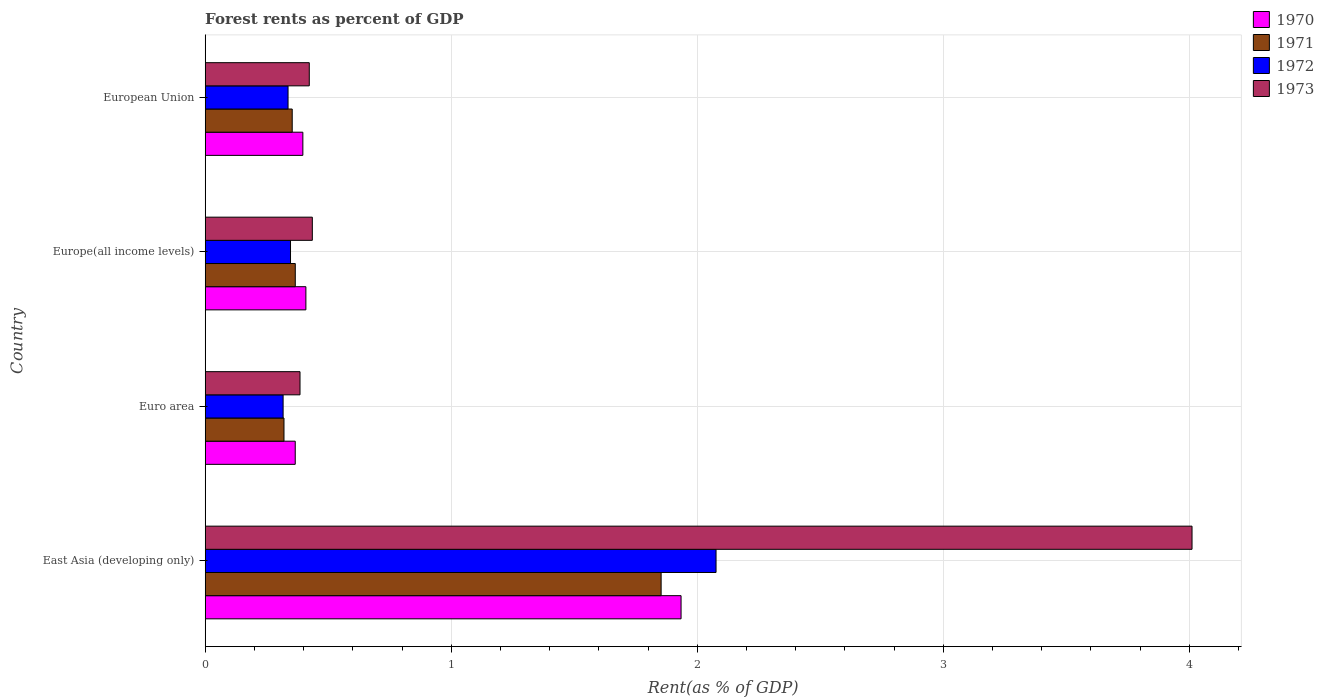How many groups of bars are there?
Give a very brief answer. 4. Are the number of bars per tick equal to the number of legend labels?
Keep it short and to the point. Yes. Are the number of bars on each tick of the Y-axis equal?
Give a very brief answer. Yes. How many bars are there on the 3rd tick from the top?
Offer a terse response. 4. How many bars are there on the 2nd tick from the bottom?
Make the answer very short. 4. What is the forest rent in 1971 in Euro area?
Ensure brevity in your answer.  0.32. Across all countries, what is the maximum forest rent in 1973?
Offer a very short reply. 4.01. Across all countries, what is the minimum forest rent in 1970?
Make the answer very short. 0.37. In which country was the forest rent in 1973 maximum?
Your answer should be very brief. East Asia (developing only). In which country was the forest rent in 1970 minimum?
Offer a very short reply. Euro area. What is the total forest rent in 1970 in the graph?
Your answer should be compact. 3.11. What is the difference between the forest rent in 1972 in East Asia (developing only) and that in European Union?
Provide a succinct answer. 1.74. What is the difference between the forest rent in 1973 in Euro area and the forest rent in 1972 in European Union?
Provide a short and direct response. 0.05. What is the average forest rent in 1970 per country?
Your answer should be very brief. 0.78. What is the difference between the forest rent in 1970 and forest rent in 1971 in Europe(all income levels)?
Give a very brief answer. 0.04. In how many countries, is the forest rent in 1973 greater than 2.6 %?
Make the answer very short. 1. What is the ratio of the forest rent in 1972 in East Asia (developing only) to that in European Union?
Ensure brevity in your answer.  6.17. What is the difference between the highest and the second highest forest rent in 1970?
Offer a very short reply. 1.52. What is the difference between the highest and the lowest forest rent in 1973?
Offer a terse response. 3.63. In how many countries, is the forest rent in 1972 greater than the average forest rent in 1972 taken over all countries?
Keep it short and to the point. 1. Is the sum of the forest rent in 1970 in Euro area and European Union greater than the maximum forest rent in 1972 across all countries?
Provide a succinct answer. No. Is it the case that in every country, the sum of the forest rent in 1970 and forest rent in 1971 is greater than the sum of forest rent in 1972 and forest rent in 1973?
Ensure brevity in your answer.  Yes. What does the 1st bar from the bottom in Europe(all income levels) represents?
Provide a succinct answer. 1970. How many countries are there in the graph?
Provide a succinct answer. 4. Does the graph contain any zero values?
Give a very brief answer. No. Does the graph contain grids?
Keep it short and to the point. Yes. How many legend labels are there?
Keep it short and to the point. 4. How are the legend labels stacked?
Provide a succinct answer. Vertical. What is the title of the graph?
Your response must be concise. Forest rents as percent of GDP. Does "1960" appear as one of the legend labels in the graph?
Keep it short and to the point. No. What is the label or title of the X-axis?
Keep it short and to the point. Rent(as % of GDP). What is the label or title of the Y-axis?
Ensure brevity in your answer.  Country. What is the Rent(as % of GDP) of 1970 in East Asia (developing only)?
Your response must be concise. 1.93. What is the Rent(as % of GDP) of 1971 in East Asia (developing only)?
Your response must be concise. 1.85. What is the Rent(as % of GDP) in 1972 in East Asia (developing only)?
Offer a terse response. 2.08. What is the Rent(as % of GDP) of 1973 in East Asia (developing only)?
Offer a very short reply. 4.01. What is the Rent(as % of GDP) of 1970 in Euro area?
Your response must be concise. 0.37. What is the Rent(as % of GDP) of 1971 in Euro area?
Provide a short and direct response. 0.32. What is the Rent(as % of GDP) in 1972 in Euro area?
Offer a very short reply. 0.32. What is the Rent(as % of GDP) of 1973 in Euro area?
Make the answer very short. 0.39. What is the Rent(as % of GDP) of 1970 in Europe(all income levels)?
Offer a very short reply. 0.41. What is the Rent(as % of GDP) of 1971 in Europe(all income levels)?
Your answer should be compact. 0.37. What is the Rent(as % of GDP) in 1972 in Europe(all income levels)?
Your response must be concise. 0.35. What is the Rent(as % of GDP) in 1973 in Europe(all income levels)?
Your answer should be compact. 0.44. What is the Rent(as % of GDP) in 1970 in European Union?
Keep it short and to the point. 0.4. What is the Rent(as % of GDP) of 1971 in European Union?
Your response must be concise. 0.35. What is the Rent(as % of GDP) of 1972 in European Union?
Provide a succinct answer. 0.34. What is the Rent(as % of GDP) in 1973 in European Union?
Keep it short and to the point. 0.42. Across all countries, what is the maximum Rent(as % of GDP) in 1970?
Offer a terse response. 1.93. Across all countries, what is the maximum Rent(as % of GDP) in 1971?
Make the answer very short. 1.85. Across all countries, what is the maximum Rent(as % of GDP) in 1972?
Ensure brevity in your answer.  2.08. Across all countries, what is the maximum Rent(as % of GDP) in 1973?
Offer a terse response. 4.01. Across all countries, what is the minimum Rent(as % of GDP) in 1970?
Make the answer very short. 0.37. Across all countries, what is the minimum Rent(as % of GDP) in 1971?
Provide a short and direct response. 0.32. Across all countries, what is the minimum Rent(as % of GDP) of 1972?
Make the answer very short. 0.32. Across all countries, what is the minimum Rent(as % of GDP) in 1973?
Make the answer very short. 0.39. What is the total Rent(as % of GDP) in 1970 in the graph?
Your answer should be very brief. 3.11. What is the total Rent(as % of GDP) of 1971 in the graph?
Give a very brief answer. 2.89. What is the total Rent(as % of GDP) in 1972 in the graph?
Your answer should be compact. 3.08. What is the total Rent(as % of GDP) of 1973 in the graph?
Keep it short and to the point. 5.25. What is the difference between the Rent(as % of GDP) of 1970 in East Asia (developing only) and that in Euro area?
Your response must be concise. 1.57. What is the difference between the Rent(as % of GDP) in 1971 in East Asia (developing only) and that in Euro area?
Provide a short and direct response. 1.53. What is the difference between the Rent(as % of GDP) of 1972 in East Asia (developing only) and that in Euro area?
Give a very brief answer. 1.76. What is the difference between the Rent(as % of GDP) of 1973 in East Asia (developing only) and that in Euro area?
Offer a very short reply. 3.63. What is the difference between the Rent(as % of GDP) in 1970 in East Asia (developing only) and that in Europe(all income levels)?
Offer a terse response. 1.52. What is the difference between the Rent(as % of GDP) in 1971 in East Asia (developing only) and that in Europe(all income levels)?
Your response must be concise. 1.49. What is the difference between the Rent(as % of GDP) of 1972 in East Asia (developing only) and that in Europe(all income levels)?
Your response must be concise. 1.73. What is the difference between the Rent(as % of GDP) in 1973 in East Asia (developing only) and that in Europe(all income levels)?
Your response must be concise. 3.58. What is the difference between the Rent(as % of GDP) of 1970 in East Asia (developing only) and that in European Union?
Provide a short and direct response. 1.54. What is the difference between the Rent(as % of GDP) in 1971 in East Asia (developing only) and that in European Union?
Your answer should be compact. 1.5. What is the difference between the Rent(as % of GDP) in 1972 in East Asia (developing only) and that in European Union?
Provide a succinct answer. 1.74. What is the difference between the Rent(as % of GDP) in 1973 in East Asia (developing only) and that in European Union?
Your response must be concise. 3.59. What is the difference between the Rent(as % of GDP) in 1970 in Euro area and that in Europe(all income levels)?
Your answer should be compact. -0.04. What is the difference between the Rent(as % of GDP) of 1971 in Euro area and that in Europe(all income levels)?
Make the answer very short. -0.05. What is the difference between the Rent(as % of GDP) in 1972 in Euro area and that in Europe(all income levels)?
Offer a very short reply. -0.03. What is the difference between the Rent(as % of GDP) in 1973 in Euro area and that in Europe(all income levels)?
Your answer should be very brief. -0.05. What is the difference between the Rent(as % of GDP) in 1970 in Euro area and that in European Union?
Keep it short and to the point. -0.03. What is the difference between the Rent(as % of GDP) of 1971 in Euro area and that in European Union?
Ensure brevity in your answer.  -0.03. What is the difference between the Rent(as % of GDP) in 1972 in Euro area and that in European Union?
Your answer should be compact. -0.02. What is the difference between the Rent(as % of GDP) of 1973 in Euro area and that in European Union?
Keep it short and to the point. -0.04. What is the difference between the Rent(as % of GDP) of 1970 in Europe(all income levels) and that in European Union?
Your answer should be very brief. 0.01. What is the difference between the Rent(as % of GDP) in 1971 in Europe(all income levels) and that in European Union?
Keep it short and to the point. 0.01. What is the difference between the Rent(as % of GDP) of 1973 in Europe(all income levels) and that in European Union?
Provide a short and direct response. 0.01. What is the difference between the Rent(as % of GDP) of 1970 in East Asia (developing only) and the Rent(as % of GDP) of 1971 in Euro area?
Make the answer very short. 1.61. What is the difference between the Rent(as % of GDP) in 1970 in East Asia (developing only) and the Rent(as % of GDP) in 1972 in Euro area?
Your response must be concise. 1.62. What is the difference between the Rent(as % of GDP) of 1970 in East Asia (developing only) and the Rent(as % of GDP) of 1973 in Euro area?
Offer a very short reply. 1.55. What is the difference between the Rent(as % of GDP) in 1971 in East Asia (developing only) and the Rent(as % of GDP) in 1972 in Euro area?
Offer a very short reply. 1.54. What is the difference between the Rent(as % of GDP) in 1971 in East Asia (developing only) and the Rent(as % of GDP) in 1973 in Euro area?
Provide a short and direct response. 1.47. What is the difference between the Rent(as % of GDP) in 1972 in East Asia (developing only) and the Rent(as % of GDP) in 1973 in Euro area?
Give a very brief answer. 1.69. What is the difference between the Rent(as % of GDP) of 1970 in East Asia (developing only) and the Rent(as % of GDP) of 1971 in Europe(all income levels)?
Ensure brevity in your answer.  1.57. What is the difference between the Rent(as % of GDP) in 1970 in East Asia (developing only) and the Rent(as % of GDP) in 1972 in Europe(all income levels)?
Ensure brevity in your answer.  1.59. What is the difference between the Rent(as % of GDP) of 1970 in East Asia (developing only) and the Rent(as % of GDP) of 1973 in Europe(all income levels)?
Ensure brevity in your answer.  1.5. What is the difference between the Rent(as % of GDP) of 1971 in East Asia (developing only) and the Rent(as % of GDP) of 1972 in Europe(all income levels)?
Provide a short and direct response. 1.51. What is the difference between the Rent(as % of GDP) in 1971 in East Asia (developing only) and the Rent(as % of GDP) in 1973 in Europe(all income levels)?
Offer a terse response. 1.42. What is the difference between the Rent(as % of GDP) in 1972 in East Asia (developing only) and the Rent(as % of GDP) in 1973 in Europe(all income levels)?
Offer a terse response. 1.64. What is the difference between the Rent(as % of GDP) in 1970 in East Asia (developing only) and the Rent(as % of GDP) in 1971 in European Union?
Give a very brief answer. 1.58. What is the difference between the Rent(as % of GDP) of 1970 in East Asia (developing only) and the Rent(as % of GDP) of 1972 in European Union?
Make the answer very short. 1.6. What is the difference between the Rent(as % of GDP) of 1970 in East Asia (developing only) and the Rent(as % of GDP) of 1973 in European Union?
Give a very brief answer. 1.51. What is the difference between the Rent(as % of GDP) of 1971 in East Asia (developing only) and the Rent(as % of GDP) of 1972 in European Union?
Provide a succinct answer. 1.52. What is the difference between the Rent(as % of GDP) in 1971 in East Asia (developing only) and the Rent(as % of GDP) in 1973 in European Union?
Your answer should be compact. 1.43. What is the difference between the Rent(as % of GDP) of 1972 in East Asia (developing only) and the Rent(as % of GDP) of 1973 in European Union?
Give a very brief answer. 1.65. What is the difference between the Rent(as % of GDP) of 1970 in Euro area and the Rent(as % of GDP) of 1971 in Europe(all income levels)?
Offer a terse response. -0. What is the difference between the Rent(as % of GDP) of 1970 in Euro area and the Rent(as % of GDP) of 1972 in Europe(all income levels)?
Make the answer very short. 0.02. What is the difference between the Rent(as % of GDP) of 1970 in Euro area and the Rent(as % of GDP) of 1973 in Europe(all income levels)?
Ensure brevity in your answer.  -0.07. What is the difference between the Rent(as % of GDP) in 1971 in Euro area and the Rent(as % of GDP) in 1972 in Europe(all income levels)?
Give a very brief answer. -0.03. What is the difference between the Rent(as % of GDP) of 1971 in Euro area and the Rent(as % of GDP) of 1973 in Europe(all income levels)?
Offer a terse response. -0.12. What is the difference between the Rent(as % of GDP) in 1972 in Euro area and the Rent(as % of GDP) in 1973 in Europe(all income levels)?
Provide a succinct answer. -0.12. What is the difference between the Rent(as % of GDP) of 1970 in Euro area and the Rent(as % of GDP) of 1971 in European Union?
Your answer should be compact. 0.01. What is the difference between the Rent(as % of GDP) of 1970 in Euro area and the Rent(as % of GDP) of 1972 in European Union?
Your answer should be compact. 0.03. What is the difference between the Rent(as % of GDP) of 1970 in Euro area and the Rent(as % of GDP) of 1973 in European Union?
Keep it short and to the point. -0.06. What is the difference between the Rent(as % of GDP) in 1971 in Euro area and the Rent(as % of GDP) in 1972 in European Union?
Offer a very short reply. -0.02. What is the difference between the Rent(as % of GDP) of 1971 in Euro area and the Rent(as % of GDP) of 1973 in European Union?
Make the answer very short. -0.1. What is the difference between the Rent(as % of GDP) in 1972 in Euro area and the Rent(as % of GDP) in 1973 in European Union?
Your answer should be very brief. -0.11. What is the difference between the Rent(as % of GDP) of 1970 in Europe(all income levels) and the Rent(as % of GDP) of 1971 in European Union?
Your answer should be very brief. 0.06. What is the difference between the Rent(as % of GDP) in 1970 in Europe(all income levels) and the Rent(as % of GDP) in 1972 in European Union?
Offer a terse response. 0.07. What is the difference between the Rent(as % of GDP) in 1970 in Europe(all income levels) and the Rent(as % of GDP) in 1973 in European Union?
Ensure brevity in your answer.  -0.01. What is the difference between the Rent(as % of GDP) in 1971 in Europe(all income levels) and the Rent(as % of GDP) in 1972 in European Union?
Offer a terse response. 0.03. What is the difference between the Rent(as % of GDP) in 1971 in Europe(all income levels) and the Rent(as % of GDP) in 1973 in European Union?
Your answer should be compact. -0.06. What is the difference between the Rent(as % of GDP) of 1972 in Europe(all income levels) and the Rent(as % of GDP) of 1973 in European Union?
Offer a terse response. -0.08. What is the average Rent(as % of GDP) in 1970 per country?
Offer a terse response. 0.78. What is the average Rent(as % of GDP) of 1971 per country?
Provide a short and direct response. 0.72. What is the average Rent(as % of GDP) of 1972 per country?
Offer a very short reply. 0.77. What is the average Rent(as % of GDP) of 1973 per country?
Keep it short and to the point. 1.31. What is the difference between the Rent(as % of GDP) of 1970 and Rent(as % of GDP) of 1971 in East Asia (developing only)?
Offer a terse response. 0.08. What is the difference between the Rent(as % of GDP) in 1970 and Rent(as % of GDP) in 1972 in East Asia (developing only)?
Make the answer very short. -0.14. What is the difference between the Rent(as % of GDP) of 1970 and Rent(as % of GDP) of 1973 in East Asia (developing only)?
Offer a very short reply. -2.08. What is the difference between the Rent(as % of GDP) in 1971 and Rent(as % of GDP) in 1972 in East Asia (developing only)?
Make the answer very short. -0.22. What is the difference between the Rent(as % of GDP) in 1971 and Rent(as % of GDP) in 1973 in East Asia (developing only)?
Give a very brief answer. -2.16. What is the difference between the Rent(as % of GDP) in 1972 and Rent(as % of GDP) in 1973 in East Asia (developing only)?
Keep it short and to the point. -1.93. What is the difference between the Rent(as % of GDP) of 1970 and Rent(as % of GDP) of 1971 in Euro area?
Offer a very short reply. 0.05. What is the difference between the Rent(as % of GDP) of 1970 and Rent(as % of GDP) of 1972 in Euro area?
Your response must be concise. 0.05. What is the difference between the Rent(as % of GDP) in 1970 and Rent(as % of GDP) in 1973 in Euro area?
Your answer should be compact. -0.02. What is the difference between the Rent(as % of GDP) in 1971 and Rent(as % of GDP) in 1972 in Euro area?
Your response must be concise. 0. What is the difference between the Rent(as % of GDP) of 1971 and Rent(as % of GDP) of 1973 in Euro area?
Ensure brevity in your answer.  -0.07. What is the difference between the Rent(as % of GDP) in 1972 and Rent(as % of GDP) in 1973 in Euro area?
Give a very brief answer. -0.07. What is the difference between the Rent(as % of GDP) of 1970 and Rent(as % of GDP) of 1971 in Europe(all income levels)?
Offer a terse response. 0.04. What is the difference between the Rent(as % of GDP) in 1970 and Rent(as % of GDP) in 1972 in Europe(all income levels)?
Your answer should be compact. 0.06. What is the difference between the Rent(as % of GDP) of 1970 and Rent(as % of GDP) of 1973 in Europe(all income levels)?
Provide a short and direct response. -0.03. What is the difference between the Rent(as % of GDP) in 1971 and Rent(as % of GDP) in 1972 in Europe(all income levels)?
Your answer should be very brief. 0.02. What is the difference between the Rent(as % of GDP) in 1971 and Rent(as % of GDP) in 1973 in Europe(all income levels)?
Your response must be concise. -0.07. What is the difference between the Rent(as % of GDP) in 1972 and Rent(as % of GDP) in 1973 in Europe(all income levels)?
Provide a succinct answer. -0.09. What is the difference between the Rent(as % of GDP) of 1970 and Rent(as % of GDP) of 1971 in European Union?
Your answer should be compact. 0.04. What is the difference between the Rent(as % of GDP) of 1970 and Rent(as % of GDP) of 1972 in European Union?
Make the answer very short. 0.06. What is the difference between the Rent(as % of GDP) in 1970 and Rent(as % of GDP) in 1973 in European Union?
Your response must be concise. -0.03. What is the difference between the Rent(as % of GDP) in 1971 and Rent(as % of GDP) in 1972 in European Union?
Ensure brevity in your answer.  0.02. What is the difference between the Rent(as % of GDP) in 1971 and Rent(as % of GDP) in 1973 in European Union?
Your answer should be compact. -0.07. What is the difference between the Rent(as % of GDP) of 1972 and Rent(as % of GDP) of 1973 in European Union?
Ensure brevity in your answer.  -0.09. What is the ratio of the Rent(as % of GDP) in 1970 in East Asia (developing only) to that in Euro area?
Your answer should be very brief. 5.28. What is the ratio of the Rent(as % of GDP) of 1971 in East Asia (developing only) to that in Euro area?
Keep it short and to the point. 5.79. What is the ratio of the Rent(as % of GDP) in 1972 in East Asia (developing only) to that in Euro area?
Your answer should be very brief. 6.56. What is the ratio of the Rent(as % of GDP) of 1973 in East Asia (developing only) to that in Euro area?
Provide a short and direct response. 10.41. What is the ratio of the Rent(as % of GDP) in 1970 in East Asia (developing only) to that in Europe(all income levels)?
Your response must be concise. 4.73. What is the ratio of the Rent(as % of GDP) of 1971 in East Asia (developing only) to that in Europe(all income levels)?
Offer a terse response. 5.06. What is the ratio of the Rent(as % of GDP) of 1972 in East Asia (developing only) to that in Europe(all income levels)?
Offer a terse response. 5.99. What is the ratio of the Rent(as % of GDP) in 1973 in East Asia (developing only) to that in Europe(all income levels)?
Make the answer very short. 9.21. What is the ratio of the Rent(as % of GDP) in 1970 in East Asia (developing only) to that in European Union?
Make the answer very short. 4.87. What is the ratio of the Rent(as % of GDP) of 1971 in East Asia (developing only) to that in European Union?
Your answer should be compact. 5.24. What is the ratio of the Rent(as % of GDP) of 1972 in East Asia (developing only) to that in European Union?
Your response must be concise. 6.17. What is the ratio of the Rent(as % of GDP) in 1973 in East Asia (developing only) to that in European Union?
Provide a succinct answer. 9.48. What is the ratio of the Rent(as % of GDP) in 1970 in Euro area to that in Europe(all income levels)?
Provide a succinct answer. 0.89. What is the ratio of the Rent(as % of GDP) in 1971 in Euro area to that in Europe(all income levels)?
Your answer should be compact. 0.87. What is the ratio of the Rent(as % of GDP) of 1972 in Euro area to that in Europe(all income levels)?
Provide a succinct answer. 0.91. What is the ratio of the Rent(as % of GDP) of 1973 in Euro area to that in Europe(all income levels)?
Your answer should be very brief. 0.88. What is the ratio of the Rent(as % of GDP) in 1970 in Euro area to that in European Union?
Give a very brief answer. 0.92. What is the ratio of the Rent(as % of GDP) of 1971 in Euro area to that in European Union?
Your answer should be compact. 0.91. What is the ratio of the Rent(as % of GDP) of 1972 in Euro area to that in European Union?
Ensure brevity in your answer.  0.94. What is the ratio of the Rent(as % of GDP) in 1973 in Euro area to that in European Union?
Ensure brevity in your answer.  0.91. What is the ratio of the Rent(as % of GDP) in 1970 in Europe(all income levels) to that in European Union?
Your response must be concise. 1.03. What is the ratio of the Rent(as % of GDP) of 1971 in Europe(all income levels) to that in European Union?
Keep it short and to the point. 1.04. What is the ratio of the Rent(as % of GDP) of 1972 in Europe(all income levels) to that in European Union?
Keep it short and to the point. 1.03. What is the ratio of the Rent(as % of GDP) of 1973 in Europe(all income levels) to that in European Union?
Your answer should be very brief. 1.03. What is the difference between the highest and the second highest Rent(as % of GDP) of 1970?
Offer a terse response. 1.52. What is the difference between the highest and the second highest Rent(as % of GDP) in 1971?
Give a very brief answer. 1.49. What is the difference between the highest and the second highest Rent(as % of GDP) in 1972?
Your response must be concise. 1.73. What is the difference between the highest and the second highest Rent(as % of GDP) in 1973?
Your response must be concise. 3.58. What is the difference between the highest and the lowest Rent(as % of GDP) in 1970?
Provide a short and direct response. 1.57. What is the difference between the highest and the lowest Rent(as % of GDP) of 1971?
Keep it short and to the point. 1.53. What is the difference between the highest and the lowest Rent(as % of GDP) in 1972?
Offer a terse response. 1.76. What is the difference between the highest and the lowest Rent(as % of GDP) in 1973?
Your answer should be very brief. 3.63. 